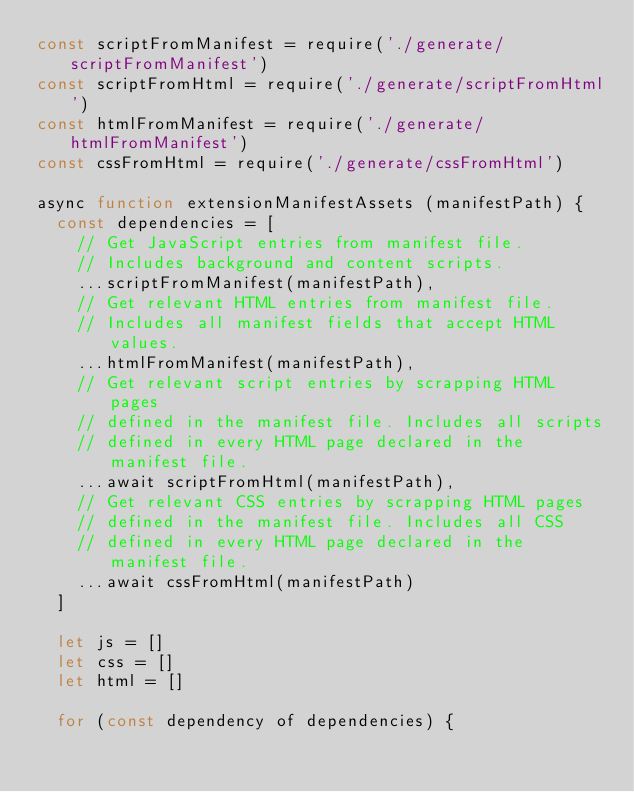<code> <loc_0><loc_0><loc_500><loc_500><_JavaScript_>const scriptFromManifest = require('./generate/scriptFromManifest')
const scriptFromHtml = require('./generate/scriptFromHtml')
const htmlFromManifest = require('./generate/htmlFromManifest')
const cssFromHtml = require('./generate/cssFromHtml')

async function extensionManifestAssets (manifestPath) {
  const dependencies = [
    // Get JavaScript entries from manifest file.
    // Includes background and content scripts.
    ...scriptFromManifest(manifestPath),
    // Get relevant HTML entries from manifest file.
    // Includes all manifest fields that accept HTML values.
    ...htmlFromManifest(manifestPath),
    // Get relevant script entries by scrapping HTML pages
    // defined in the manifest file. Includes all scripts
    // defined in every HTML page declared in the manifest file.
    ...await scriptFromHtml(manifestPath),
    // Get relevant CSS entries by scrapping HTML pages
    // defined in the manifest file. Includes all CSS
    // defined in every HTML page declared in the manifest file.
    ...await cssFromHtml(manifestPath)
  ]

  let js = []
  let css = []
  let html = []

  for (const dependency of dependencies) {</code> 